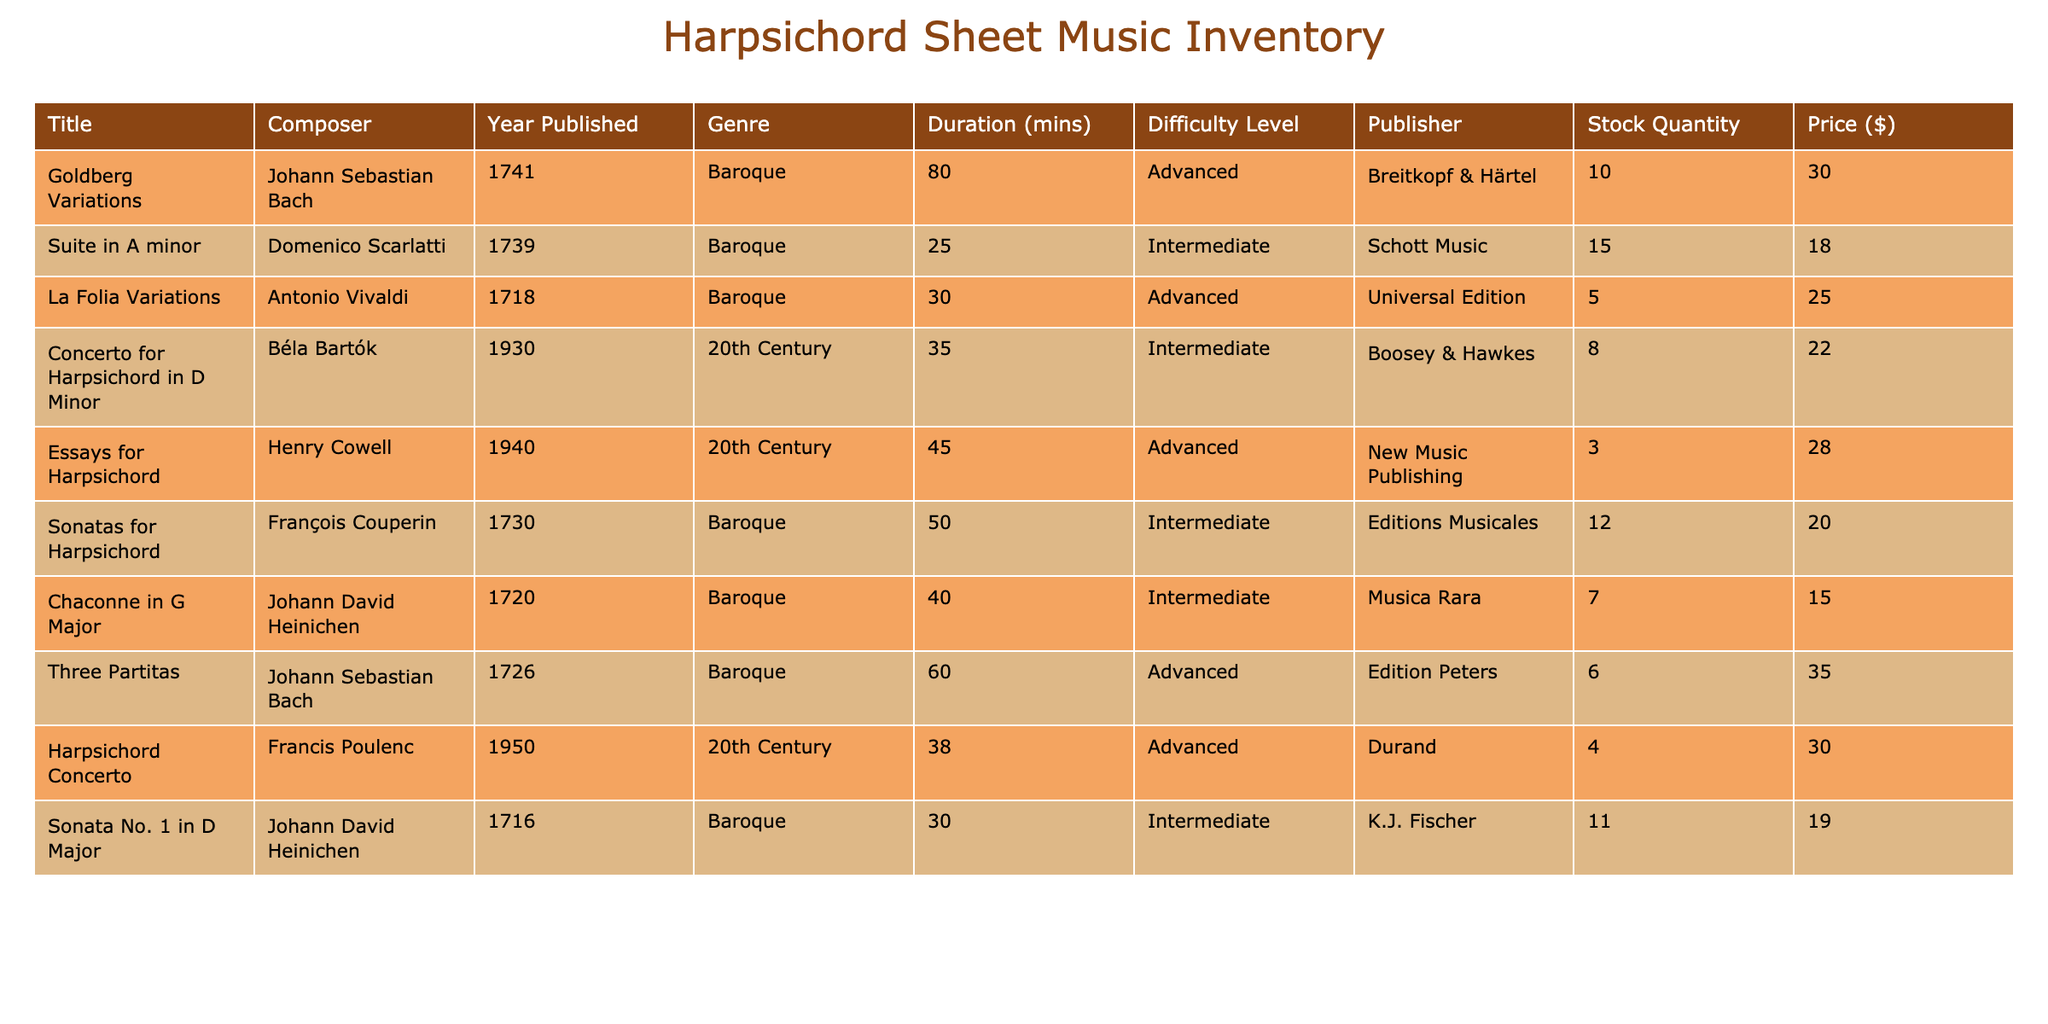What is the stock quantity for "La Folia Variations"? The table lists "La Folia Variations" and states that the stock quantity for this piece is 5.
Answer: 5 Which composer has the highest priced sheet music? By checking the "Price ($)" column, "Three Partitas" by Johann Sebastian Bach is priced at $35.00, which is the highest among all entries.
Answer: Johann Sebastian Bach Is there sheet music by Francis Poulenc in stock? The inventory shows that "Harpsichord Concerto" by Francis Poulenc has a stock quantity of 4, which indicates it is in stock.
Answer: Yes What is the total duration of all pieces by Johann Sebastian Bach? The durations of works by Bach are 80 mins (Goldberg Variations) and 60 mins (Three Partitas), summing them gives 80 + 60 = 140 mins.
Answer: 140 mins What is the average price of the sheet music listed? To find the average, sum up all the prices: 30 + 18 + 25 + 22 + 28 + 20 + 15 + 35 + 30 + 19 =  302. There are 10 pieces, so the average price is 302 / 10 = 30.20.
Answer: 30.20 How many pieces have a difficulty level of "Advanced"? By counting the rows in the difficulty level column marked as "Advanced," there are 4 pieces (Goldberg Variations, La Folia Variations, Essays for Harpsichord, and Three Partitas).
Answer: 4 What is the price difference between the most expensive and the cheapest item? The most expensive item is "Three Partitas" at $35.00 and the cheapest is "Chaconne in G Major" at $15.00. The difference is 35 - 15 = 20.
Answer: 20 How many composers have published sheet music in the 20th Century? The composers who have published in the 20th Century are Béla Bartók, Henry Cowell, and Francis Poulenc, totaling to 3 composers.
Answer: 3 Which genre has the highest stock quantity in total? The Baroque genre includes pieces with quantities of 10, 15, 5, 12, 7, 11, which sums up to 60. The 20th Century has 8, 3, and 4, which sums up to 15. The Baroque genre has the highest quantity overall.
Answer: Baroque 